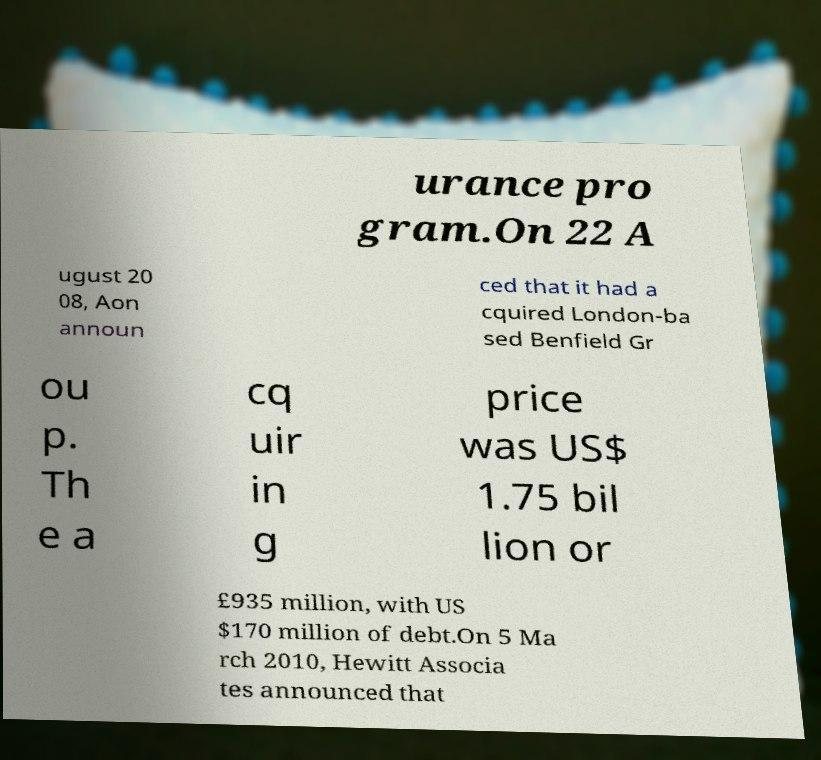I need the written content from this picture converted into text. Can you do that? urance pro gram.On 22 A ugust 20 08, Aon announ ced that it had a cquired London-ba sed Benfield Gr ou p. Th e a cq uir in g price was US$ 1.75 bil lion or £935 million, with US $170 million of debt.On 5 Ma rch 2010, Hewitt Associa tes announced that 